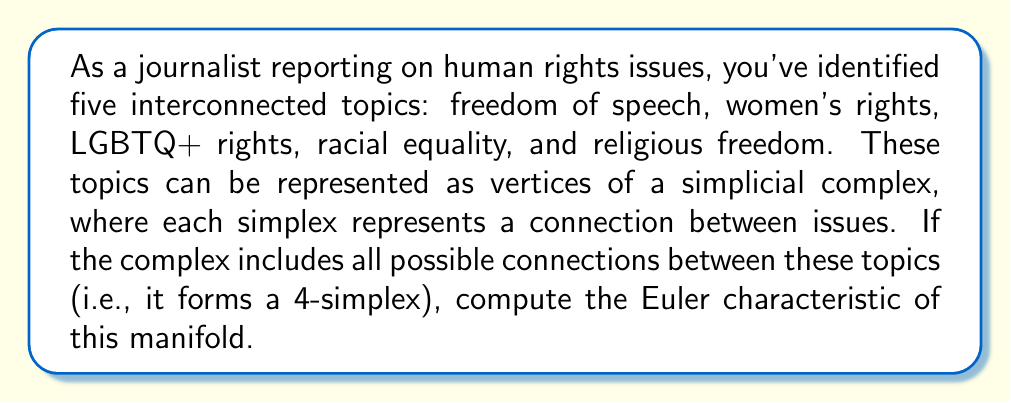Teach me how to tackle this problem. To solve this problem, we need to follow these steps:

1) First, let's recall the formula for the Euler characteristic of a simplicial complex:

   $$\chi = \sum_{k=0}^n (-1)^k f_k$$

   where $f_k$ is the number of k-dimensional simplices.

2) In our case, we have a 4-simplex (since we have 5 vertices, and all possible connections are included). Let's count the simplices of each dimension:

   - 0-simplices (vertices): $f_0 = 5$
   - 1-simplices (edges): $f_1 = \binom{5}{2} = 10$
   - 2-simplices (triangles): $f_2 = \binom{5}{3} = 10$
   - 3-simplices (tetrahedra): $f_3 = \binom{5}{4} = 5$
   - 4-simplices (4-simplex): $f_4 = \binom{5}{5} = 1$

3) Now, let's apply the formula:

   $$\chi = f_0 - f_1 + f_2 - f_3 + f_4$$
   $$\chi = 5 - 10 + 10 - 5 + 1$$

4) Calculating:

   $$\chi = 1$$

This result is consistent with the fact that a 4-simplex is homeomorphic to a 4-dimensional ball, which has an Euler characteristic of 1.
Answer: The Euler characteristic of the manifold is 1. 